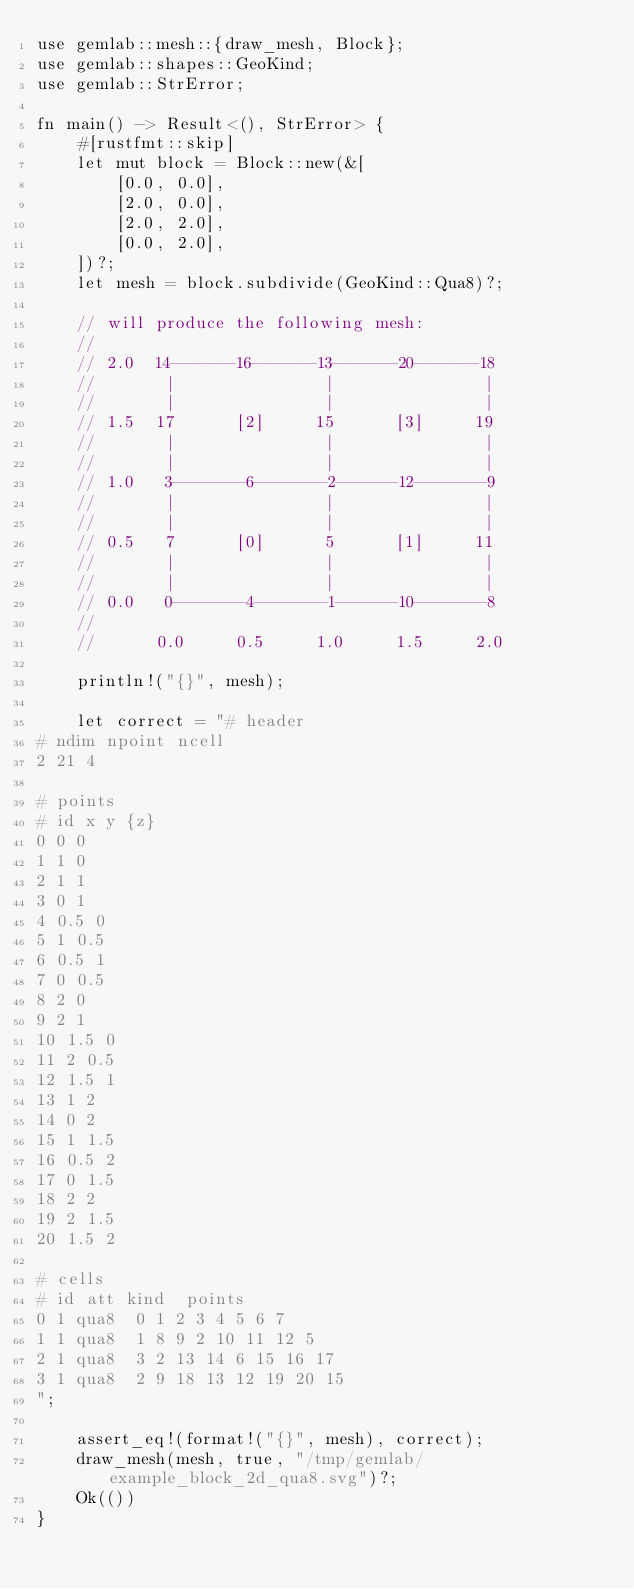<code> <loc_0><loc_0><loc_500><loc_500><_Rust_>use gemlab::mesh::{draw_mesh, Block};
use gemlab::shapes::GeoKind;
use gemlab::StrError;

fn main() -> Result<(), StrError> {
    #[rustfmt::skip]
    let mut block = Block::new(&[
        [0.0, 0.0],
        [2.0, 0.0],
        [2.0, 2.0],
        [0.0, 2.0],
    ])?;
    let mesh = block.subdivide(GeoKind::Qua8)?;

    // will produce the following mesh:
    //
    // 2.0  14------16------13------20------18
    //       |               |               |
    //       |               |               |
    // 1.5  17      [2]     15      [3]     19
    //       |               |               |
    //       |               |               |
    // 1.0   3-------6-------2------12-------9
    //       |               |               |
    //       |               |               |
    // 0.5   7      [0]      5      [1]     11
    //       |               |               |
    //       |               |               |
    // 0.0   0-------4-------1------10-------8
    //
    //      0.0     0.5     1.0     1.5     2.0

    println!("{}", mesh);

    let correct = "# header
# ndim npoint ncell
2 21 4

# points
# id x y {z}
0 0 0
1 1 0
2 1 1
3 0 1
4 0.5 0
5 1 0.5
6 0.5 1
7 0 0.5
8 2 0
9 2 1
10 1.5 0
11 2 0.5
12 1.5 1
13 1 2
14 0 2
15 1 1.5
16 0.5 2
17 0 1.5
18 2 2
19 2 1.5
20 1.5 2

# cells
# id att kind  points
0 1 qua8  0 1 2 3 4 5 6 7
1 1 qua8  1 8 9 2 10 11 12 5
2 1 qua8  3 2 13 14 6 15 16 17
3 1 qua8  2 9 18 13 12 19 20 15
";

    assert_eq!(format!("{}", mesh), correct);
    draw_mesh(mesh, true, "/tmp/gemlab/example_block_2d_qua8.svg")?;
    Ok(())
}
</code> 